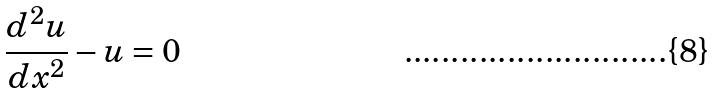<formula> <loc_0><loc_0><loc_500><loc_500>\frac { d ^ { 2 } u } { d x ^ { 2 } } - u = 0</formula> 